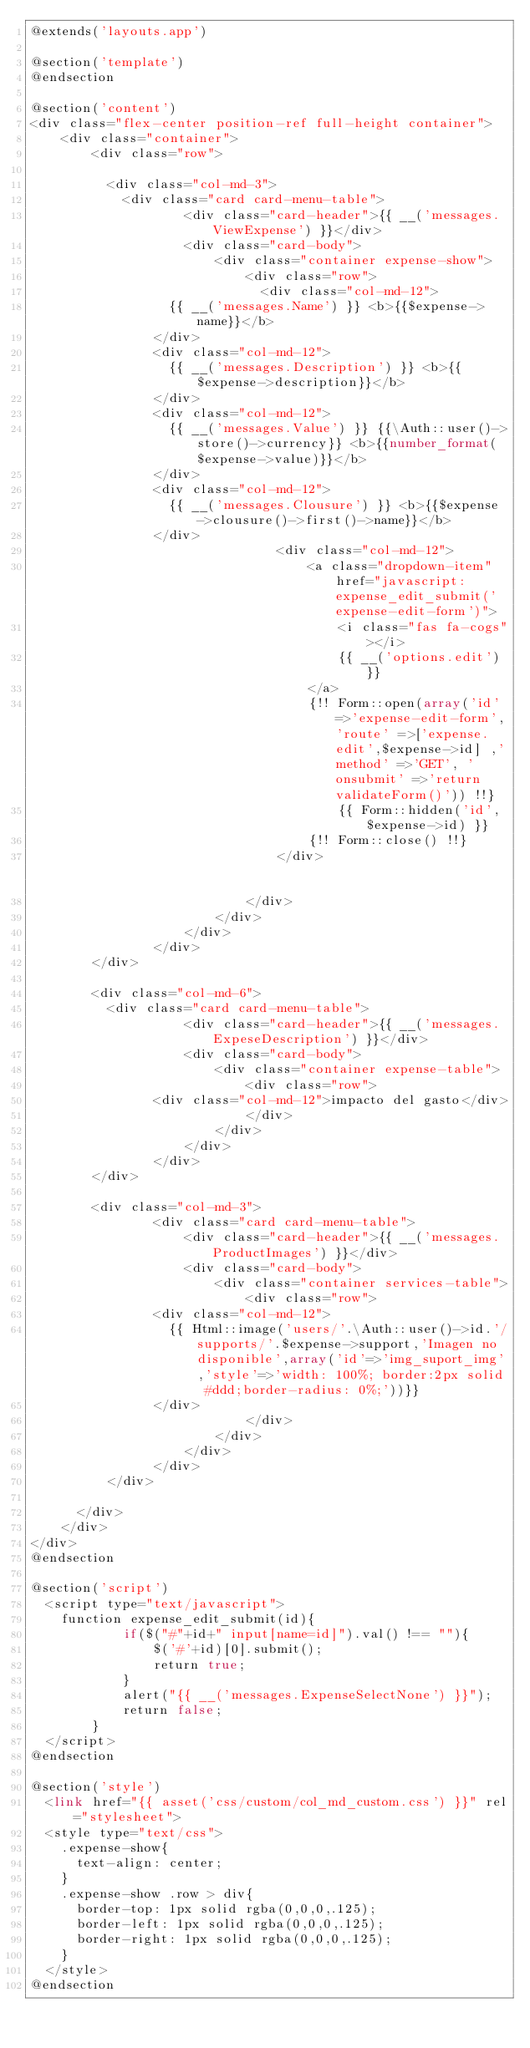Convert code to text. <code><loc_0><loc_0><loc_500><loc_500><_PHP_>@extends('layouts.app')

@section('template')		          	
@endsection

@section('content')
<div class="flex-center position-ref full-height container">    
    <div class="container">
        <div class="row">

        	<div class="col-md-3">
        		<div class="card card-menu-table">
                    <div class="card-header">{{ __('messages.ViewExpense') }}</div>
                    <div class="card-body">
                        <div class="container expense-show">
                            <div class="row">
                            	<div class="col-md-12">
									{{ __('messages.Name') }} <b>{{$expense->name}}</b>
								</div>                             
								<div class="col-md-12">
									{{ __('messages.Description') }} <b>{{$expense->description}}</b>
								</div>                             
								<div class="col-md-12">
									{{ __('messages.Value') }} {{\Auth::user()->store()->currency}} <b>{{number_format($expense->value)}}</b>
								</div>
								<div class="col-md-12">
									{{ __('messages.Clousure') }} <b>{{$expense->clousure()->first()->name}}</b>
								</div>
                                <div class="col-md-12">
                                    <a class="dropdown-item" href="javascript: expense_edit_submit('expense-edit-form')">
                                        <i class="fas fa-cogs"></i>
                                        {{ __('options.edit') }}
                                    </a>
                                    {!! Form::open(array('id'=>'expense-edit-form','route' =>['expense.edit',$expense->id] ,'method' =>'GET', 'onsubmit' =>'return validateForm()')) !!}
                                        {{ Form::hidden('id',$expense->id) }}                            
                                    {!! Form::close() !!}
                                </div>                              							
                            </div>                                                  
                        </div>                  
                    </div>                            
                </div>
    		</div>

    		<div class="col-md-6">
    			<div class="card card-menu-table">
                    <div class="card-header">{{ __('messages.ExpeseDescription') }}</div>
                    <div class="card-body">
                        <div class="container expense-table">
                            <div class="row">                                
								<div class="col-md-12">impacto del gasto</div>
                            </div>                                                  
                        </div>                  
                    </div>                            
                </div>
    		</div>

    		<div class="col-md-3">	        		
                <div class="card card-menu-table">
                    <div class="card-header">{{ __('messages.ProductImages') }}</div>
                    <div class="card-body">
                        <div class="container services-table">
                            <div class="row">                                
								<div class="col-md-12">
									{{ Html::image('users/'.\Auth::user()->id.'/supports/'.$expense->support,'Imagen no disponible',array('id'=>'img_suport_img','style'=>'width: 100%; border:2px solid #ddd;border-radius: 0%;'))}}
								</div>									
                            </div>                                                  
                        </div>                  
                    </div>                            
                </div>	                
        	</div>	

    	</div>
    </div>
</div>
@endsection

@section('script')
	<script type="text/javascript">
		function expense_edit_submit(id){
            if($("#"+id+" input[name=id]").val() !== ""){
                $('#'+id)[0].submit();
                return true;
            }
            alert("{{ __('messages.ExpenseSelectNone') }}");
            return false;           
        }
	</script>
@endsection

@section('style')	
	<link href="{{ asset('css/custom/col_md_custom.css') }}" rel="stylesheet"> 
	<style type="text/css">
		.expense-show{
			text-align: center;
		}
		.expense-show .row > div{
			border-top: 1px solid rgba(0,0,0,.125);
			border-left: 1px solid rgba(0,0,0,.125);
			border-right: 1px solid rgba(0,0,0,.125);
		}
	</style>	
@endsection
</code> 